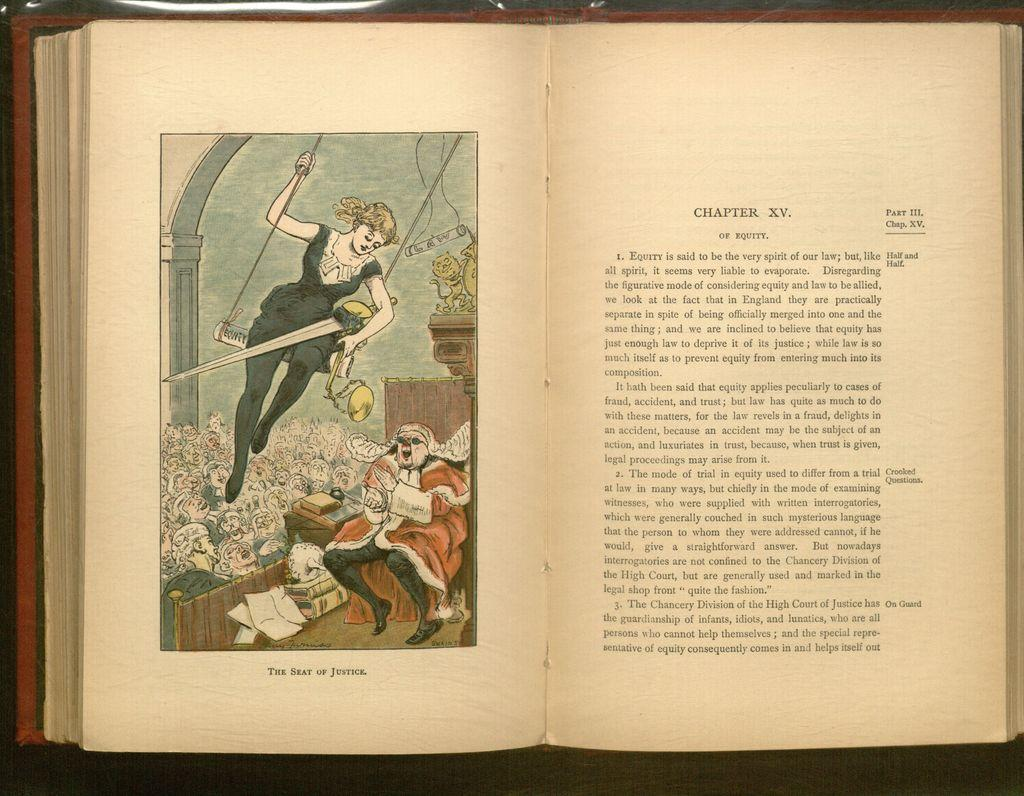Provide a one-sentence caption for the provided image. An open book with an illustration of a women above the words The seat of Justice. 